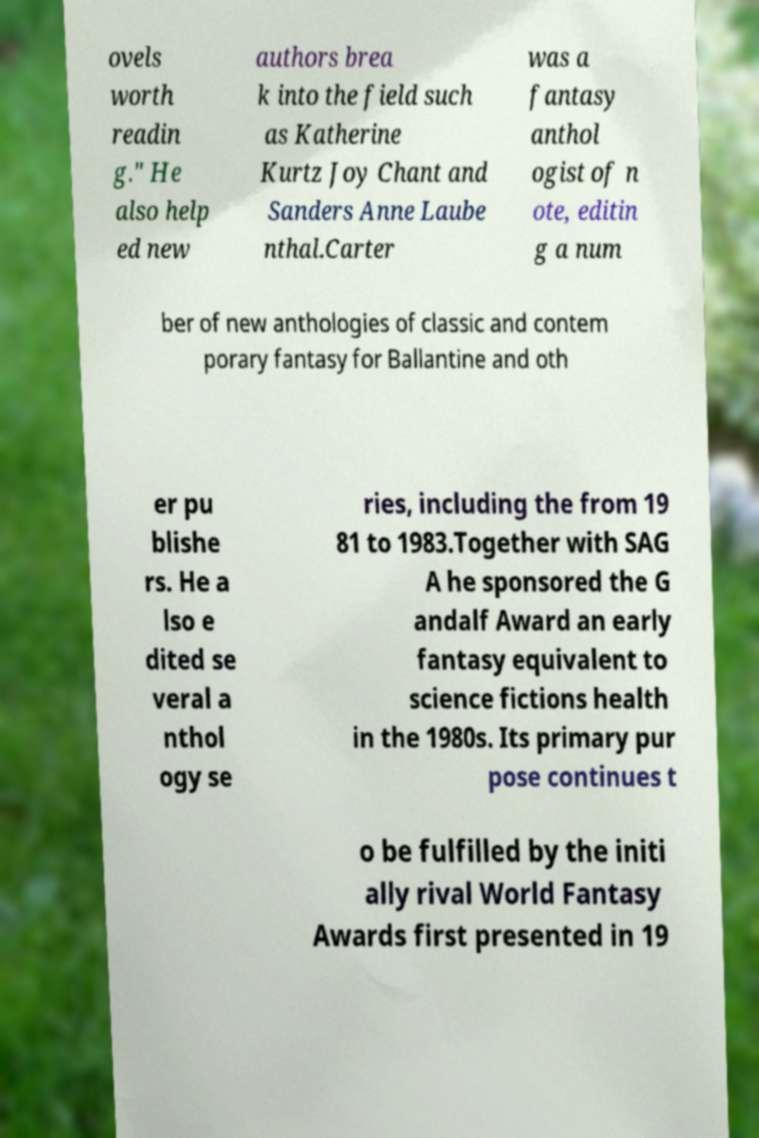I need the written content from this picture converted into text. Can you do that? ovels worth readin g." He also help ed new authors brea k into the field such as Katherine Kurtz Joy Chant and Sanders Anne Laube nthal.Carter was a fantasy anthol ogist of n ote, editin g a num ber of new anthologies of classic and contem porary fantasy for Ballantine and oth er pu blishe rs. He a lso e dited se veral a nthol ogy se ries, including the from 19 81 to 1983.Together with SAG A he sponsored the G andalf Award an early fantasy equivalent to science fictions health in the 1980s. Its primary pur pose continues t o be fulfilled by the initi ally rival World Fantasy Awards first presented in 19 